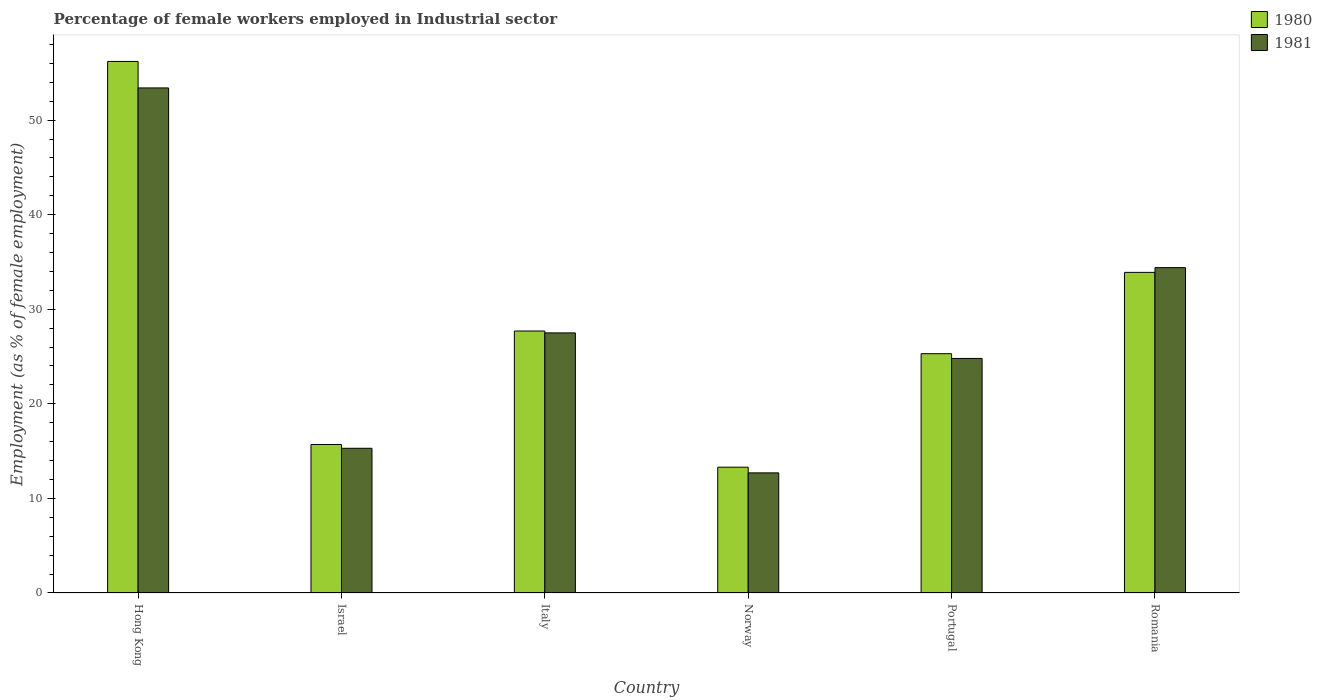Are the number of bars per tick equal to the number of legend labels?
Offer a very short reply. Yes. Are the number of bars on each tick of the X-axis equal?
Ensure brevity in your answer.  Yes. How many bars are there on the 1st tick from the left?
Keep it short and to the point. 2. How many bars are there on the 4th tick from the right?
Your answer should be very brief. 2. What is the label of the 1st group of bars from the left?
Your response must be concise. Hong Kong. In how many cases, is the number of bars for a given country not equal to the number of legend labels?
Offer a very short reply. 0. What is the percentage of females employed in Industrial sector in 1980 in Israel?
Give a very brief answer. 15.7. Across all countries, what is the maximum percentage of females employed in Industrial sector in 1980?
Keep it short and to the point. 56.2. Across all countries, what is the minimum percentage of females employed in Industrial sector in 1981?
Provide a succinct answer. 12.7. In which country was the percentage of females employed in Industrial sector in 1980 maximum?
Provide a succinct answer. Hong Kong. In which country was the percentage of females employed in Industrial sector in 1980 minimum?
Your answer should be very brief. Norway. What is the total percentage of females employed in Industrial sector in 1980 in the graph?
Offer a very short reply. 172.1. What is the difference between the percentage of females employed in Industrial sector in 1980 in Hong Kong and that in Portugal?
Offer a very short reply. 30.9. What is the difference between the percentage of females employed in Industrial sector in 1980 in Norway and the percentage of females employed in Industrial sector in 1981 in Hong Kong?
Make the answer very short. -40.1. What is the average percentage of females employed in Industrial sector in 1981 per country?
Offer a very short reply. 28.02. What is the difference between the percentage of females employed in Industrial sector of/in 1981 and percentage of females employed in Industrial sector of/in 1980 in Portugal?
Provide a succinct answer. -0.5. In how many countries, is the percentage of females employed in Industrial sector in 1981 greater than 48 %?
Provide a succinct answer. 1. What is the ratio of the percentage of females employed in Industrial sector in 1981 in Israel to that in Romania?
Your answer should be compact. 0.44. Is the percentage of females employed in Industrial sector in 1980 in Italy less than that in Portugal?
Your response must be concise. No. Is the difference between the percentage of females employed in Industrial sector in 1981 in Israel and Italy greater than the difference between the percentage of females employed in Industrial sector in 1980 in Israel and Italy?
Ensure brevity in your answer.  No. What is the difference between the highest and the second highest percentage of females employed in Industrial sector in 1981?
Offer a terse response. 6.9. What is the difference between the highest and the lowest percentage of females employed in Industrial sector in 1981?
Make the answer very short. 40.7. What does the 1st bar from the left in Portugal represents?
Provide a short and direct response. 1980. Are all the bars in the graph horizontal?
Offer a terse response. No. What is the difference between two consecutive major ticks on the Y-axis?
Your answer should be very brief. 10. Are the values on the major ticks of Y-axis written in scientific E-notation?
Your response must be concise. No. Does the graph contain grids?
Give a very brief answer. No. How many legend labels are there?
Offer a very short reply. 2. What is the title of the graph?
Offer a very short reply. Percentage of female workers employed in Industrial sector. What is the label or title of the X-axis?
Provide a short and direct response. Country. What is the label or title of the Y-axis?
Keep it short and to the point. Employment (as % of female employment). What is the Employment (as % of female employment) in 1980 in Hong Kong?
Offer a very short reply. 56.2. What is the Employment (as % of female employment) in 1981 in Hong Kong?
Provide a short and direct response. 53.4. What is the Employment (as % of female employment) of 1980 in Israel?
Offer a very short reply. 15.7. What is the Employment (as % of female employment) of 1981 in Israel?
Offer a terse response. 15.3. What is the Employment (as % of female employment) in 1980 in Italy?
Your response must be concise. 27.7. What is the Employment (as % of female employment) in 1981 in Italy?
Offer a very short reply. 27.5. What is the Employment (as % of female employment) in 1980 in Norway?
Provide a succinct answer. 13.3. What is the Employment (as % of female employment) of 1981 in Norway?
Give a very brief answer. 12.7. What is the Employment (as % of female employment) of 1980 in Portugal?
Ensure brevity in your answer.  25.3. What is the Employment (as % of female employment) of 1981 in Portugal?
Your answer should be very brief. 24.8. What is the Employment (as % of female employment) of 1980 in Romania?
Make the answer very short. 33.9. What is the Employment (as % of female employment) in 1981 in Romania?
Your response must be concise. 34.4. Across all countries, what is the maximum Employment (as % of female employment) of 1980?
Make the answer very short. 56.2. Across all countries, what is the maximum Employment (as % of female employment) in 1981?
Keep it short and to the point. 53.4. Across all countries, what is the minimum Employment (as % of female employment) in 1980?
Ensure brevity in your answer.  13.3. Across all countries, what is the minimum Employment (as % of female employment) in 1981?
Provide a short and direct response. 12.7. What is the total Employment (as % of female employment) of 1980 in the graph?
Provide a succinct answer. 172.1. What is the total Employment (as % of female employment) of 1981 in the graph?
Your answer should be compact. 168.1. What is the difference between the Employment (as % of female employment) of 1980 in Hong Kong and that in Israel?
Ensure brevity in your answer.  40.5. What is the difference between the Employment (as % of female employment) of 1981 in Hong Kong and that in Israel?
Give a very brief answer. 38.1. What is the difference between the Employment (as % of female employment) of 1980 in Hong Kong and that in Italy?
Your answer should be very brief. 28.5. What is the difference between the Employment (as % of female employment) in 1981 in Hong Kong and that in Italy?
Make the answer very short. 25.9. What is the difference between the Employment (as % of female employment) in 1980 in Hong Kong and that in Norway?
Make the answer very short. 42.9. What is the difference between the Employment (as % of female employment) in 1981 in Hong Kong and that in Norway?
Ensure brevity in your answer.  40.7. What is the difference between the Employment (as % of female employment) in 1980 in Hong Kong and that in Portugal?
Provide a succinct answer. 30.9. What is the difference between the Employment (as % of female employment) of 1981 in Hong Kong and that in Portugal?
Ensure brevity in your answer.  28.6. What is the difference between the Employment (as % of female employment) in 1980 in Hong Kong and that in Romania?
Your answer should be compact. 22.3. What is the difference between the Employment (as % of female employment) of 1981 in Hong Kong and that in Romania?
Your response must be concise. 19. What is the difference between the Employment (as % of female employment) in 1980 in Israel and that in Romania?
Give a very brief answer. -18.2. What is the difference between the Employment (as % of female employment) of 1981 in Israel and that in Romania?
Make the answer very short. -19.1. What is the difference between the Employment (as % of female employment) in 1981 in Italy and that in Portugal?
Offer a very short reply. 2.7. What is the difference between the Employment (as % of female employment) of 1980 in Norway and that in Portugal?
Your answer should be very brief. -12. What is the difference between the Employment (as % of female employment) of 1980 in Norway and that in Romania?
Make the answer very short. -20.6. What is the difference between the Employment (as % of female employment) in 1981 in Norway and that in Romania?
Ensure brevity in your answer.  -21.7. What is the difference between the Employment (as % of female employment) of 1980 in Hong Kong and the Employment (as % of female employment) of 1981 in Israel?
Provide a short and direct response. 40.9. What is the difference between the Employment (as % of female employment) in 1980 in Hong Kong and the Employment (as % of female employment) in 1981 in Italy?
Give a very brief answer. 28.7. What is the difference between the Employment (as % of female employment) of 1980 in Hong Kong and the Employment (as % of female employment) of 1981 in Norway?
Offer a terse response. 43.5. What is the difference between the Employment (as % of female employment) of 1980 in Hong Kong and the Employment (as % of female employment) of 1981 in Portugal?
Ensure brevity in your answer.  31.4. What is the difference between the Employment (as % of female employment) in 1980 in Hong Kong and the Employment (as % of female employment) in 1981 in Romania?
Your answer should be very brief. 21.8. What is the difference between the Employment (as % of female employment) of 1980 in Israel and the Employment (as % of female employment) of 1981 in Norway?
Ensure brevity in your answer.  3. What is the difference between the Employment (as % of female employment) of 1980 in Israel and the Employment (as % of female employment) of 1981 in Romania?
Your answer should be compact. -18.7. What is the difference between the Employment (as % of female employment) of 1980 in Italy and the Employment (as % of female employment) of 1981 in Norway?
Ensure brevity in your answer.  15. What is the difference between the Employment (as % of female employment) of 1980 in Italy and the Employment (as % of female employment) of 1981 in Portugal?
Provide a short and direct response. 2.9. What is the difference between the Employment (as % of female employment) of 1980 in Norway and the Employment (as % of female employment) of 1981 in Romania?
Offer a terse response. -21.1. What is the average Employment (as % of female employment) of 1980 per country?
Your answer should be compact. 28.68. What is the average Employment (as % of female employment) in 1981 per country?
Your response must be concise. 28.02. What is the difference between the Employment (as % of female employment) in 1980 and Employment (as % of female employment) in 1981 in Hong Kong?
Ensure brevity in your answer.  2.8. What is the difference between the Employment (as % of female employment) in 1980 and Employment (as % of female employment) in 1981 in Israel?
Provide a succinct answer. 0.4. What is the difference between the Employment (as % of female employment) in 1980 and Employment (as % of female employment) in 1981 in Italy?
Offer a very short reply. 0.2. What is the difference between the Employment (as % of female employment) of 1980 and Employment (as % of female employment) of 1981 in Norway?
Your answer should be compact. 0.6. What is the difference between the Employment (as % of female employment) of 1980 and Employment (as % of female employment) of 1981 in Portugal?
Make the answer very short. 0.5. What is the difference between the Employment (as % of female employment) of 1980 and Employment (as % of female employment) of 1981 in Romania?
Your response must be concise. -0.5. What is the ratio of the Employment (as % of female employment) of 1980 in Hong Kong to that in Israel?
Your answer should be compact. 3.58. What is the ratio of the Employment (as % of female employment) in 1981 in Hong Kong to that in Israel?
Keep it short and to the point. 3.49. What is the ratio of the Employment (as % of female employment) of 1980 in Hong Kong to that in Italy?
Your response must be concise. 2.03. What is the ratio of the Employment (as % of female employment) in 1981 in Hong Kong to that in Italy?
Offer a terse response. 1.94. What is the ratio of the Employment (as % of female employment) of 1980 in Hong Kong to that in Norway?
Keep it short and to the point. 4.23. What is the ratio of the Employment (as % of female employment) of 1981 in Hong Kong to that in Norway?
Provide a short and direct response. 4.2. What is the ratio of the Employment (as % of female employment) in 1980 in Hong Kong to that in Portugal?
Your response must be concise. 2.22. What is the ratio of the Employment (as % of female employment) of 1981 in Hong Kong to that in Portugal?
Your response must be concise. 2.15. What is the ratio of the Employment (as % of female employment) in 1980 in Hong Kong to that in Romania?
Offer a very short reply. 1.66. What is the ratio of the Employment (as % of female employment) of 1981 in Hong Kong to that in Romania?
Provide a short and direct response. 1.55. What is the ratio of the Employment (as % of female employment) of 1980 in Israel to that in Italy?
Keep it short and to the point. 0.57. What is the ratio of the Employment (as % of female employment) in 1981 in Israel to that in Italy?
Offer a very short reply. 0.56. What is the ratio of the Employment (as % of female employment) of 1980 in Israel to that in Norway?
Offer a terse response. 1.18. What is the ratio of the Employment (as % of female employment) of 1981 in Israel to that in Norway?
Offer a very short reply. 1.2. What is the ratio of the Employment (as % of female employment) of 1980 in Israel to that in Portugal?
Provide a short and direct response. 0.62. What is the ratio of the Employment (as % of female employment) of 1981 in Israel to that in Portugal?
Ensure brevity in your answer.  0.62. What is the ratio of the Employment (as % of female employment) of 1980 in Israel to that in Romania?
Your answer should be compact. 0.46. What is the ratio of the Employment (as % of female employment) of 1981 in Israel to that in Romania?
Ensure brevity in your answer.  0.44. What is the ratio of the Employment (as % of female employment) in 1980 in Italy to that in Norway?
Your answer should be compact. 2.08. What is the ratio of the Employment (as % of female employment) of 1981 in Italy to that in Norway?
Keep it short and to the point. 2.17. What is the ratio of the Employment (as % of female employment) of 1980 in Italy to that in Portugal?
Ensure brevity in your answer.  1.09. What is the ratio of the Employment (as % of female employment) of 1981 in Italy to that in Portugal?
Make the answer very short. 1.11. What is the ratio of the Employment (as % of female employment) in 1980 in Italy to that in Romania?
Give a very brief answer. 0.82. What is the ratio of the Employment (as % of female employment) of 1981 in Italy to that in Romania?
Give a very brief answer. 0.8. What is the ratio of the Employment (as % of female employment) of 1980 in Norway to that in Portugal?
Give a very brief answer. 0.53. What is the ratio of the Employment (as % of female employment) in 1981 in Norway to that in Portugal?
Make the answer very short. 0.51. What is the ratio of the Employment (as % of female employment) of 1980 in Norway to that in Romania?
Ensure brevity in your answer.  0.39. What is the ratio of the Employment (as % of female employment) of 1981 in Norway to that in Romania?
Keep it short and to the point. 0.37. What is the ratio of the Employment (as % of female employment) in 1980 in Portugal to that in Romania?
Provide a succinct answer. 0.75. What is the ratio of the Employment (as % of female employment) of 1981 in Portugal to that in Romania?
Your answer should be very brief. 0.72. What is the difference between the highest and the second highest Employment (as % of female employment) of 1980?
Keep it short and to the point. 22.3. What is the difference between the highest and the lowest Employment (as % of female employment) in 1980?
Keep it short and to the point. 42.9. What is the difference between the highest and the lowest Employment (as % of female employment) of 1981?
Offer a terse response. 40.7. 